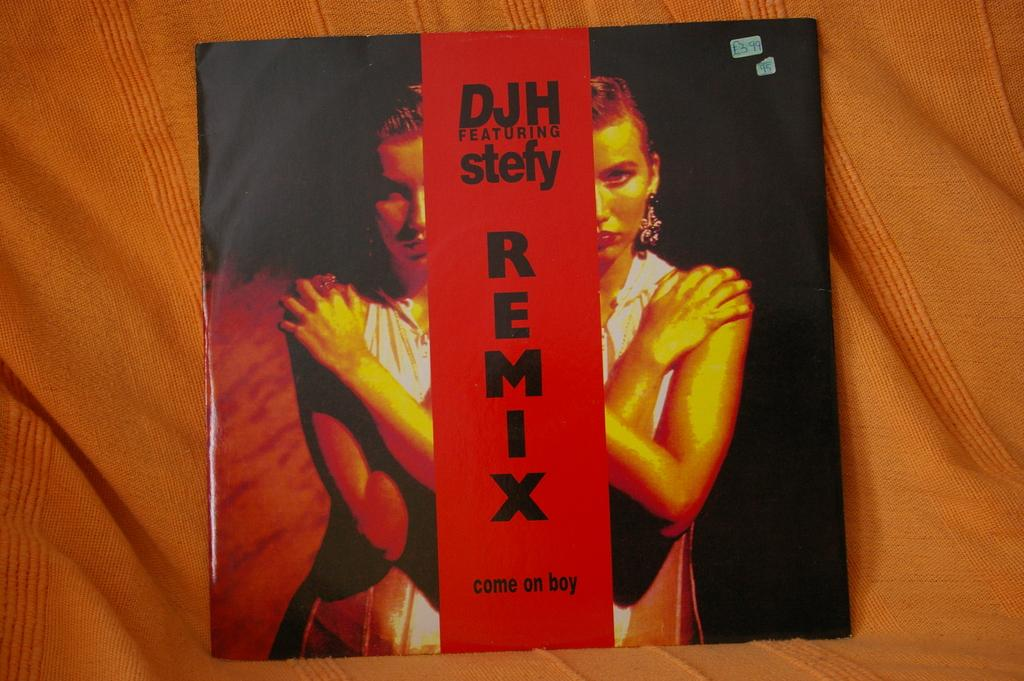<image>
Offer a succinct explanation of the picture presented. A CD cover with the title DJH featuring stefy Remix. 